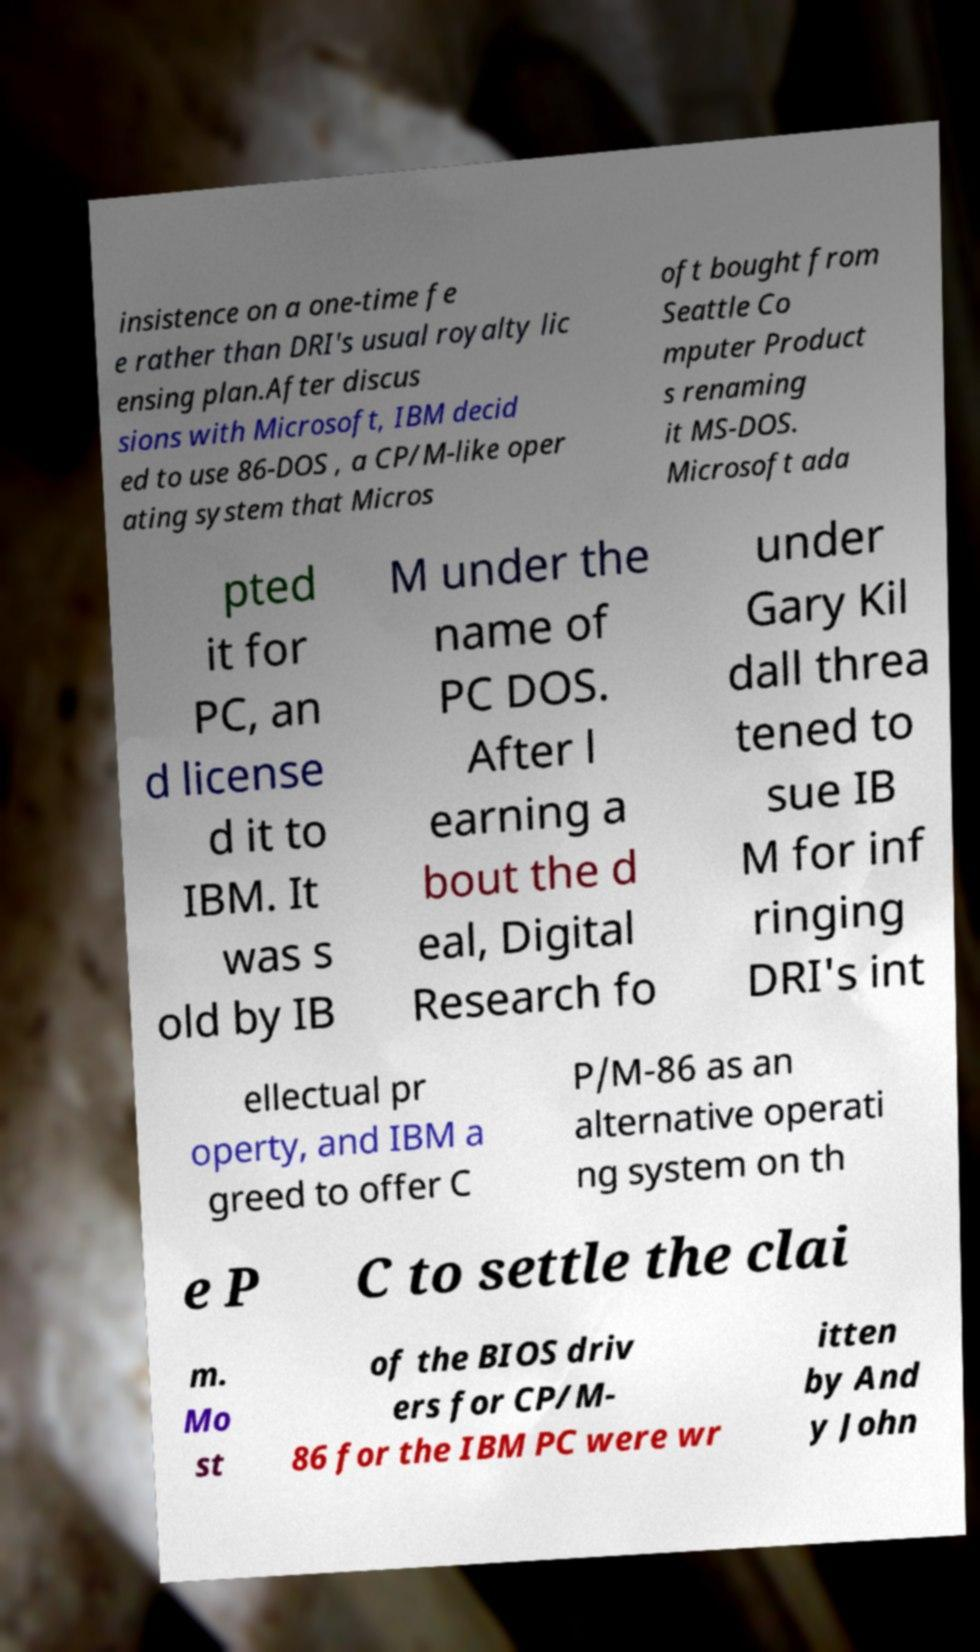What messages or text are displayed in this image? I need them in a readable, typed format. insistence on a one-time fe e rather than DRI's usual royalty lic ensing plan.After discus sions with Microsoft, IBM decid ed to use 86-DOS , a CP/M-like oper ating system that Micros oft bought from Seattle Co mputer Product s renaming it MS-DOS. Microsoft ada pted it for PC, an d license d it to IBM. It was s old by IB M under the name of PC DOS. After l earning a bout the d eal, Digital Research fo under Gary Kil dall threa tened to sue IB M for inf ringing DRI's int ellectual pr operty, and IBM a greed to offer C P/M-86 as an alternative operati ng system on th e P C to settle the clai m. Mo st of the BIOS driv ers for CP/M- 86 for the IBM PC were wr itten by And y John 